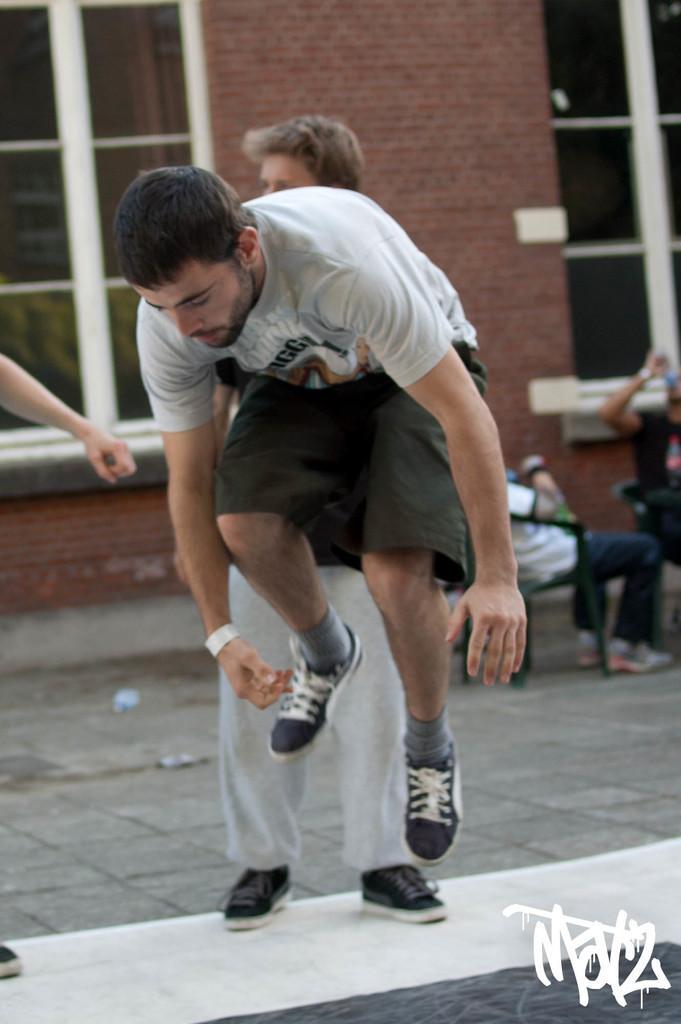Could you give a brief overview of what you see in this image? In the picture I can see a person wearing T-shirt, socks and shoes is in the air. In the background, I can see another person standing on the wall, on the left side of the image I can see a person's hand. The background of the image is slightly blurred, where we can see two persons on the right side of the image and I can see a building with glass windows. Here I can see the watermark at the bottom right side of the image. 